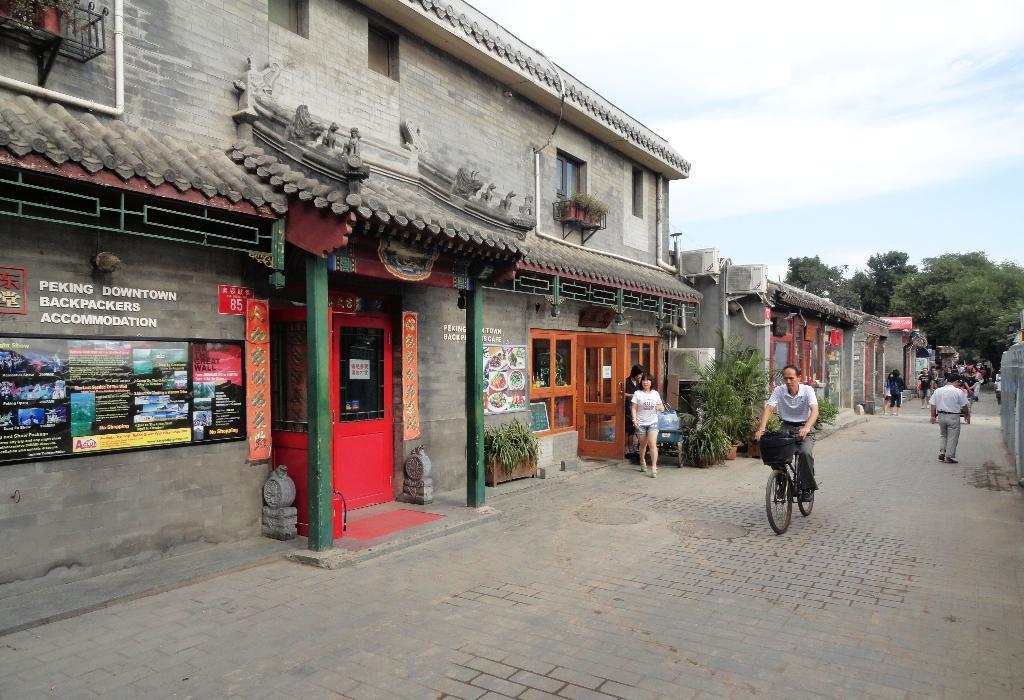Please provide a concise description of this image. In this image there are houses, plants, trees, bicycle, people, doors, pillars, cloudy sky and objects. Something is written on the boards.   